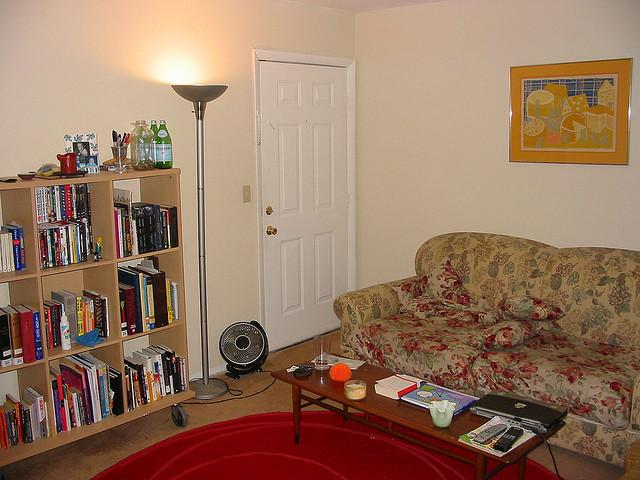Which electronic device is likely located in front of the coffee table? Please explain your reasoning. television. It is a normal device for this room and there are remotes on the table 